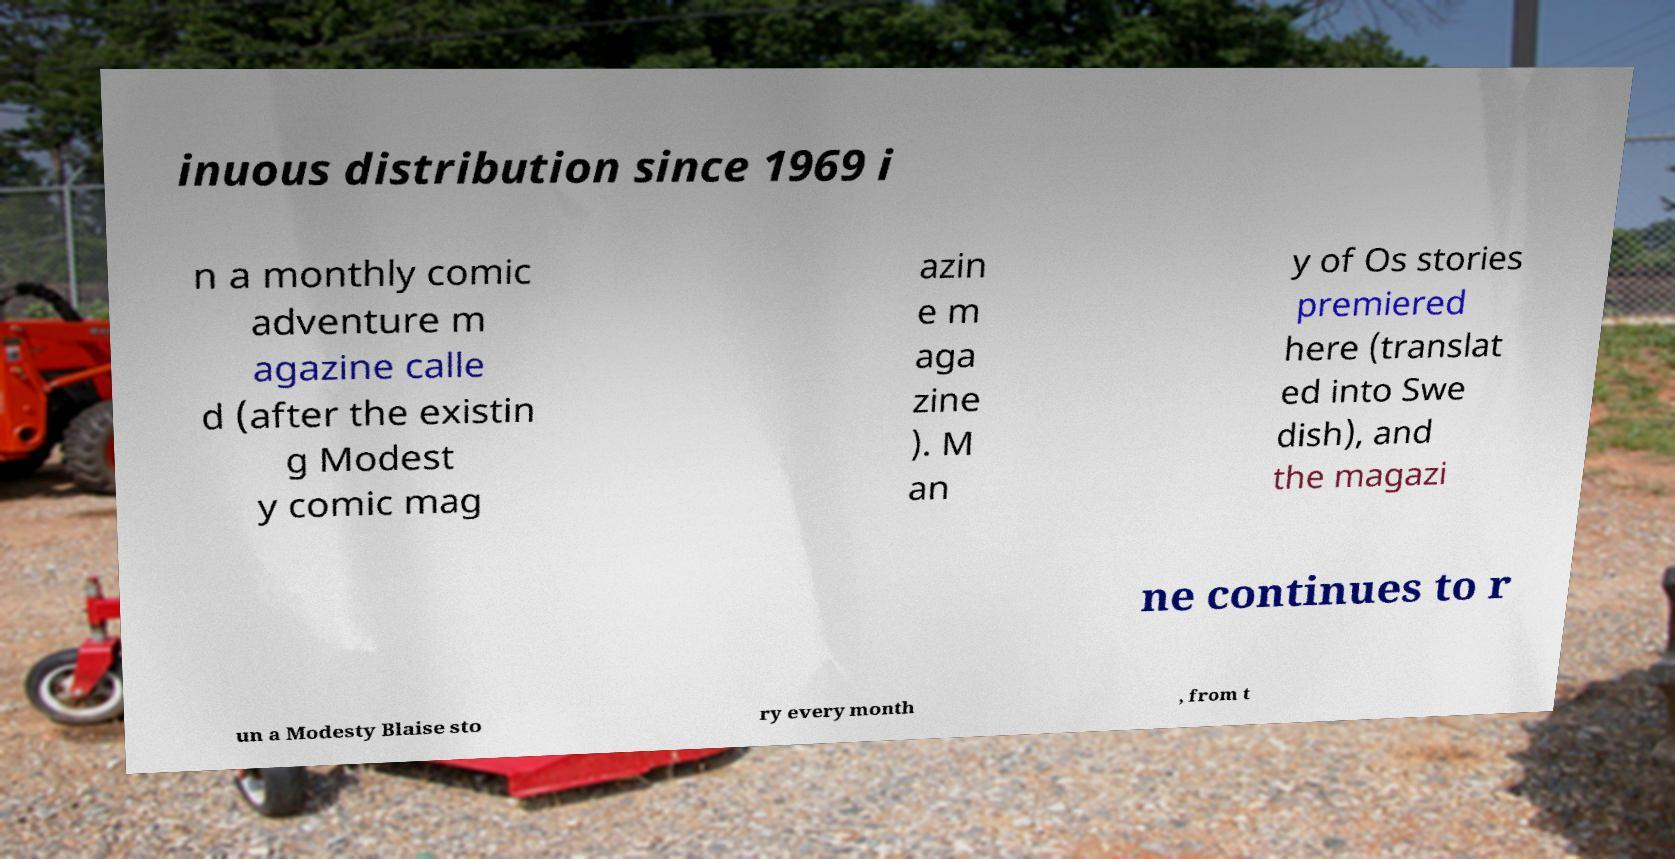There's text embedded in this image that I need extracted. Can you transcribe it verbatim? inuous distribution since 1969 i n a monthly comic adventure m agazine calle d (after the existin g Modest y comic mag azin e m aga zine ). M an y of Os stories premiered here (translat ed into Swe dish), and the magazi ne continues to r un a Modesty Blaise sto ry every month , from t 